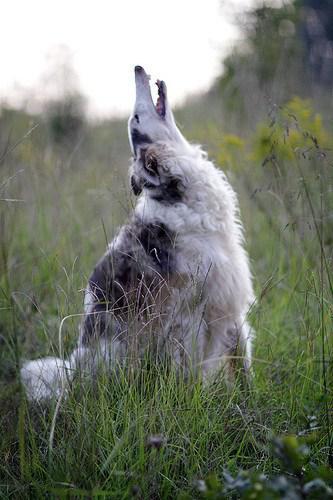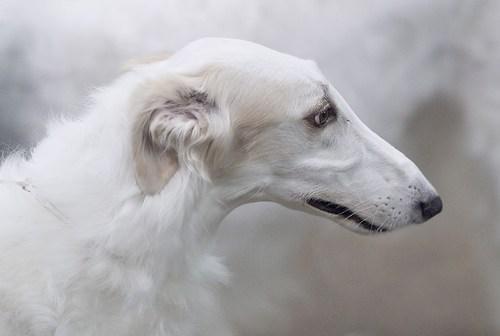The first image is the image on the left, the second image is the image on the right. For the images shown, is this caption "Each image shows exactly one dog standing on all fours outdoors." true? Answer yes or no. No. The first image is the image on the left, the second image is the image on the right. Considering the images on both sides, is "All the dogs are standing on all fours in the grass." valid? Answer yes or no. No. 